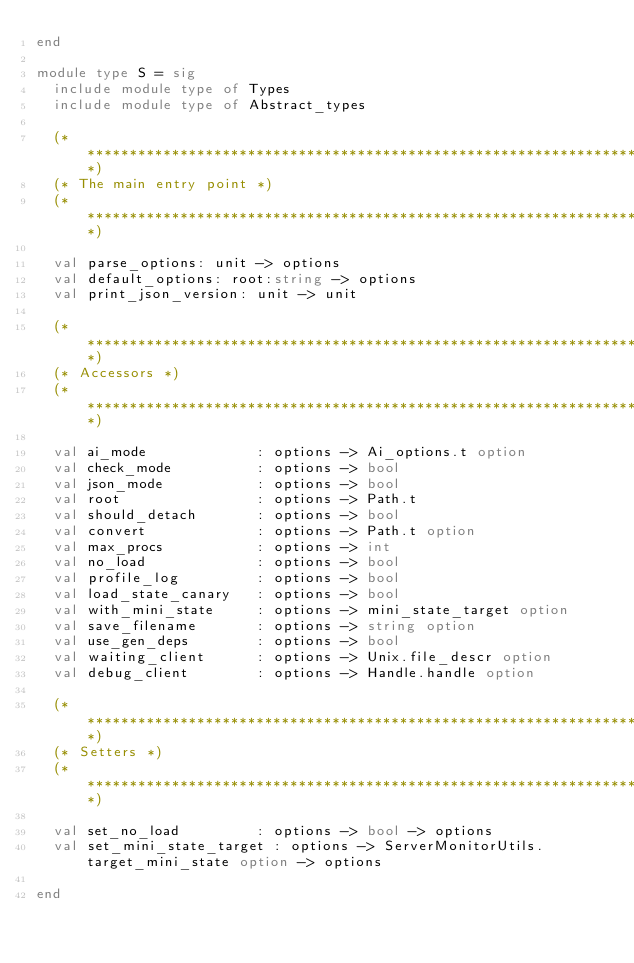Convert code to text. <code><loc_0><loc_0><loc_500><loc_500><_OCaml_>end

module type S = sig
  include module type of Types
  include module type of Abstract_types

  (****************************************************************************)
  (* The main entry point *)
  (****************************************************************************)

  val parse_options: unit -> options
  val default_options: root:string -> options
  val print_json_version: unit -> unit

  (****************************************************************************)
  (* Accessors *)
  (****************************************************************************)

  val ai_mode             : options -> Ai_options.t option
  val check_mode          : options -> bool
  val json_mode           : options -> bool
  val root                : options -> Path.t
  val should_detach       : options -> bool
  val convert             : options -> Path.t option
  val max_procs           : options -> int
  val no_load             : options -> bool
  val profile_log         : options -> bool
  val load_state_canary   : options -> bool
  val with_mini_state     : options -> mini_state_target option
  val save_filename       : options -> string option
  val use_gen_deps        : options -> bool
  val waiting_client      : options -> Unix.file_descr option
  val debug_client        : options -> Handle.handle option

  (****************************************************************************)
  (* Setters *)
  (****************************************************************************)

  val set_no_load         : options -> bool -> options
  val set_mini_state_target : options -> ServerMonitorUtils.target_mini_state option -> options

end
</code> 